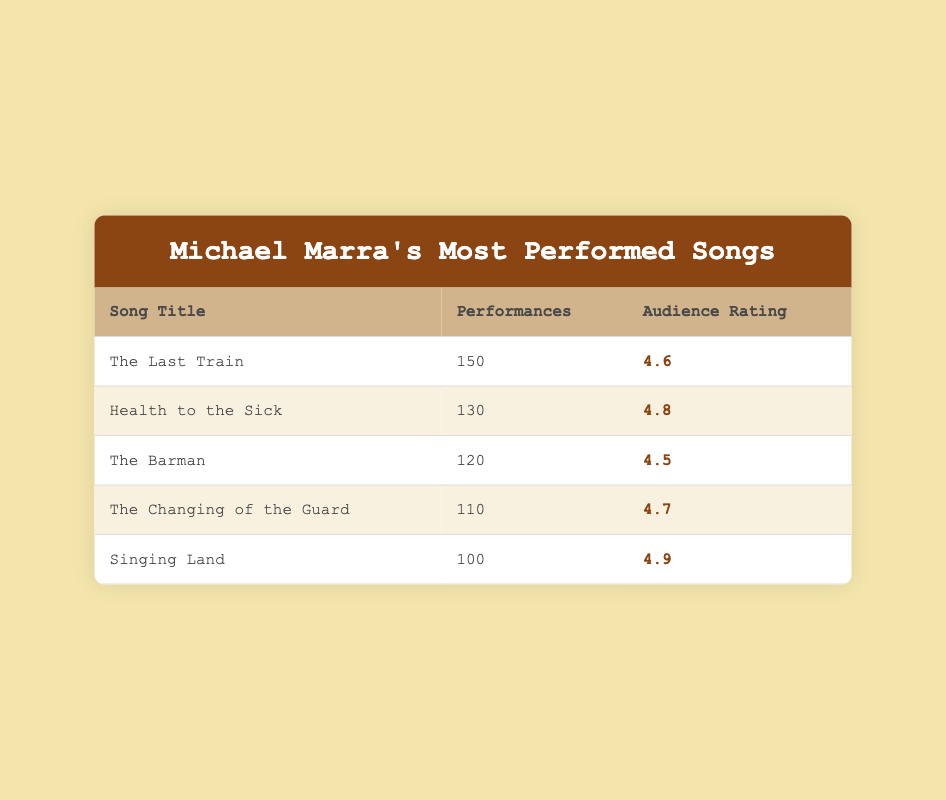What is the most performed song by Michael Marra? The song with the highest number of performances listed in the table is "The Last Train," which has 150 performances.
Answer: The Last Train Which song has the highest audience rating? Looking at the audience ratings, "Singing Land" has the highest rating of 4.9.
Answer: Singing Land How many total performances do the top three songs have? The top three songs are "The Last Train" (150), "Health to the Sick" (130), and "The Barman" (120). Summing these values gives us 150 + 130 + 120 = 400 total performances.
Answer: 400 Is the audience rating for "The Barman" higher than 4.5? "The Barman" has an audience rating of 4.5, which is not higher than 4.5; it is equal.
Answer: No What is the average audience rating of the five songs? To calculate the average, first add the audience ratings: 4.6 + 4.8 + 4.5 + 4.7 + 4.9 = 24.5. Then, divide by the number of songs (5): 24.5 / 5 = 4.9.
Answer: 4.9 How many more performances does "Health to the Sick" have than "Singing Land"? "Health to the Sick" has 130 performances, while "Singing Land" has 100 performances. The difference is calculated as 130 - 100 = 30.
Answer: 30 Which song has a performance count that is more than 120? The songs with more than 120 performances are "The Last Train" (150) and "Health to the Sick" (130) and "The Barman" (120).
Answer: The Last Train, Health to the Sick, The Barman Are there any songs with an audience rating of less than 4.5? The song "The Barman" has an audience rating of exactly 4.5, but there are no songs with a rating lower than 4.5.
Answer: No 